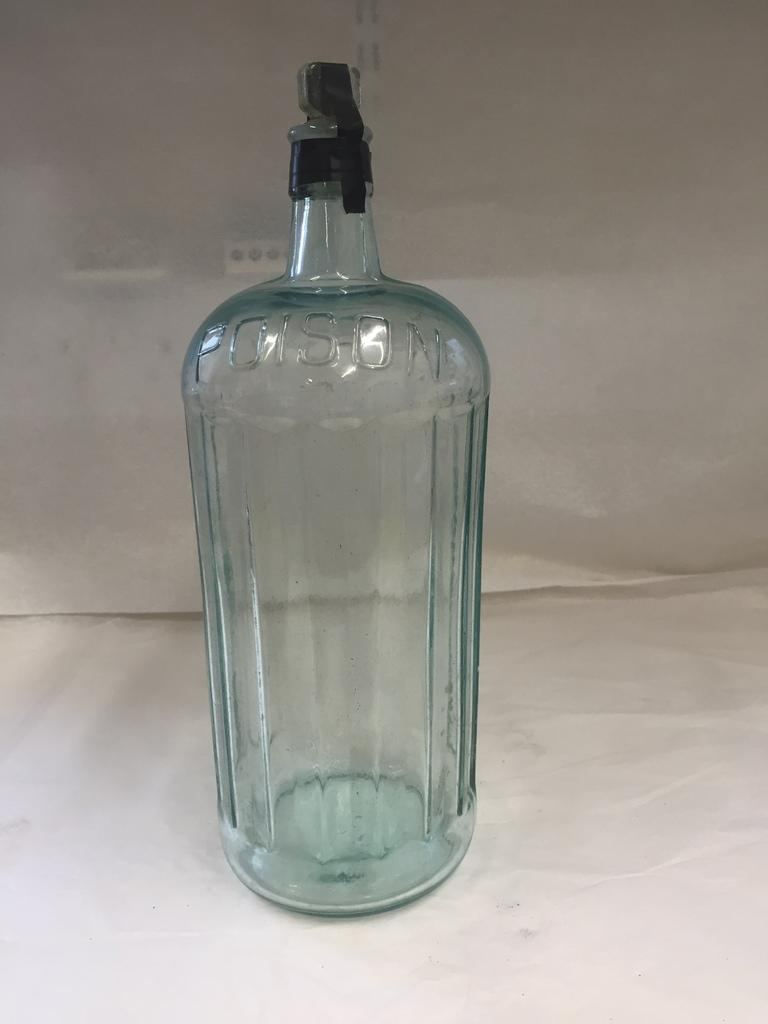What object can be seen in the image? There is a glass bottle in the image. What type of wool can be seen coming from the kittens in the image? There are no kittens or wool present in the image; it only features a glass bottle. 